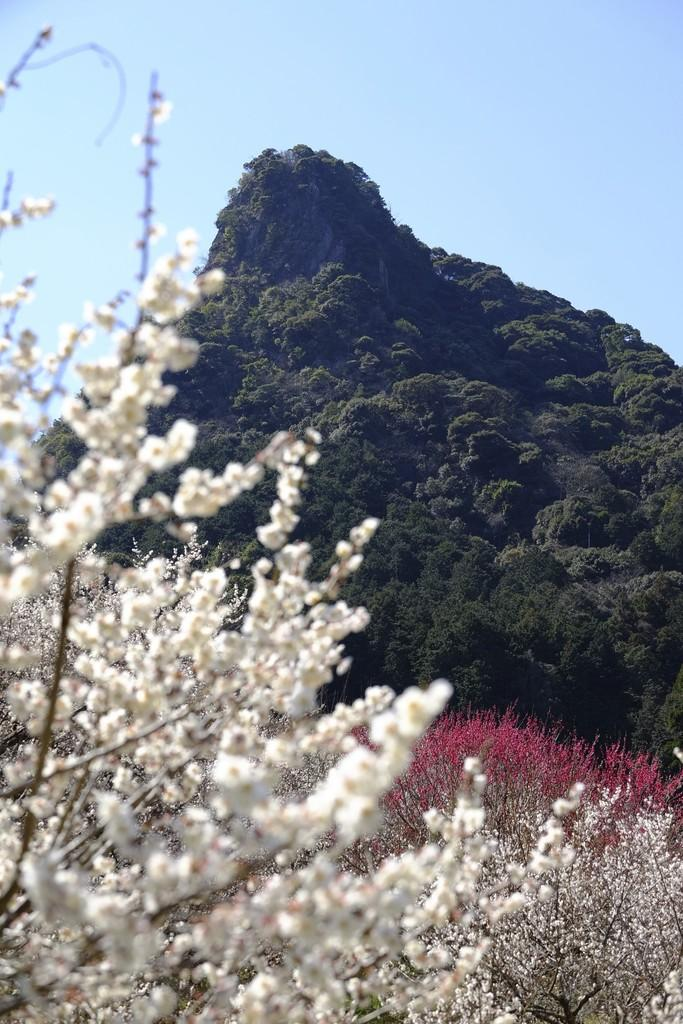What types of flowers are present in the image? There are white and pink flowers in the image. What can be seen in the distance behind the flowers? Mountains and trees are visible in the background of the image. What color is the sky in the image? The sky is blue in the image. What type of magic is being performed with the flowers in the image? There is no magic or any indication of a magical process in the image; it simply shows flowers, mountains, trees, and a blue sky. 